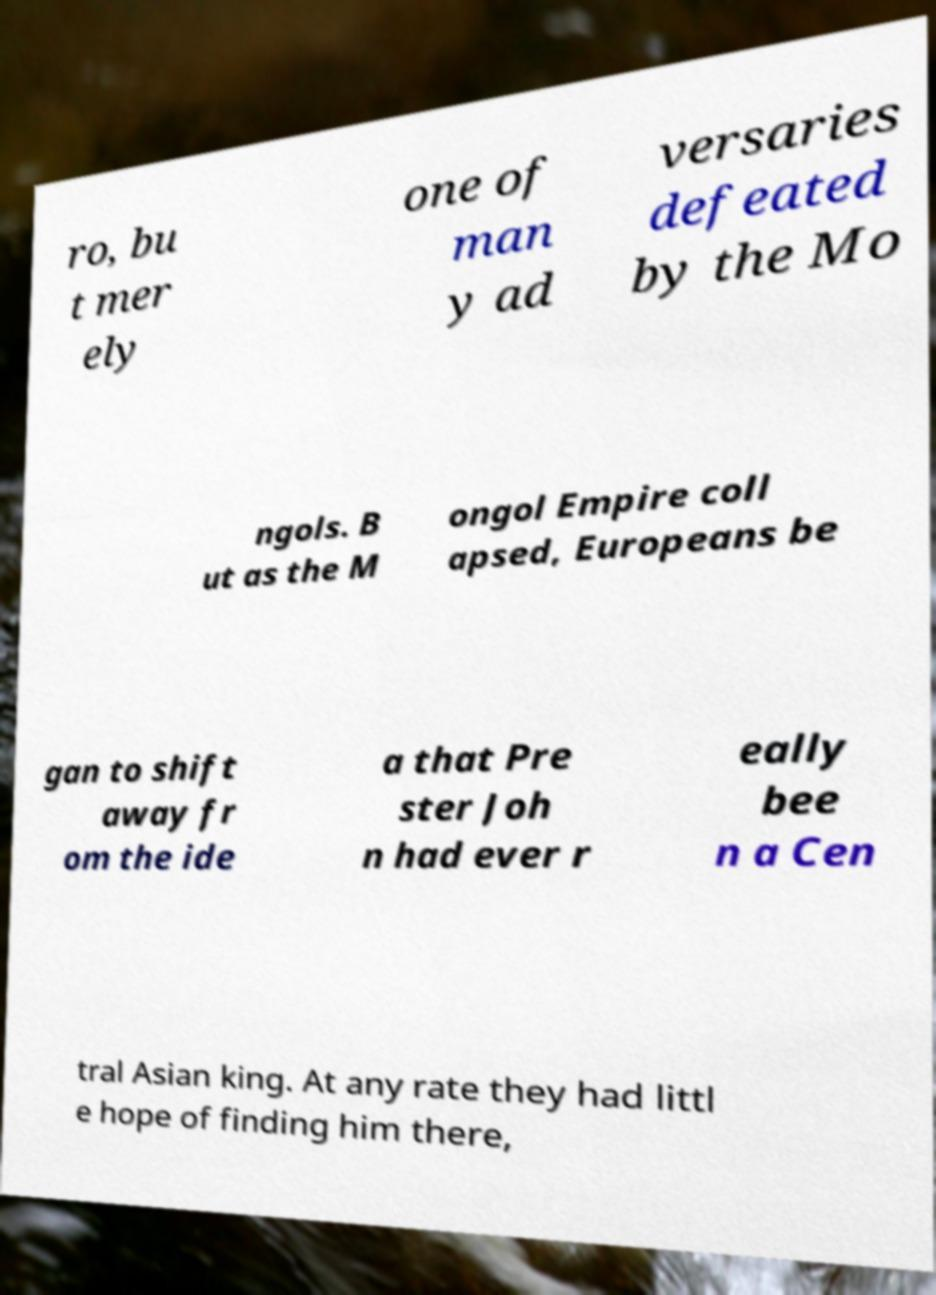What messages or text are displayed in this image? I need them in a readable, typed format. ro, bu t mer ely one of man y ad versaries defeated by the Mo ngols. B ut as the M ongol Empire coll apsed, Europeans be gan to shift away fr om the ide a that Pre ster Joh n had ever r eally bee n a Cen tral Asian king. At any rate they had littl e hope of finding him there, 